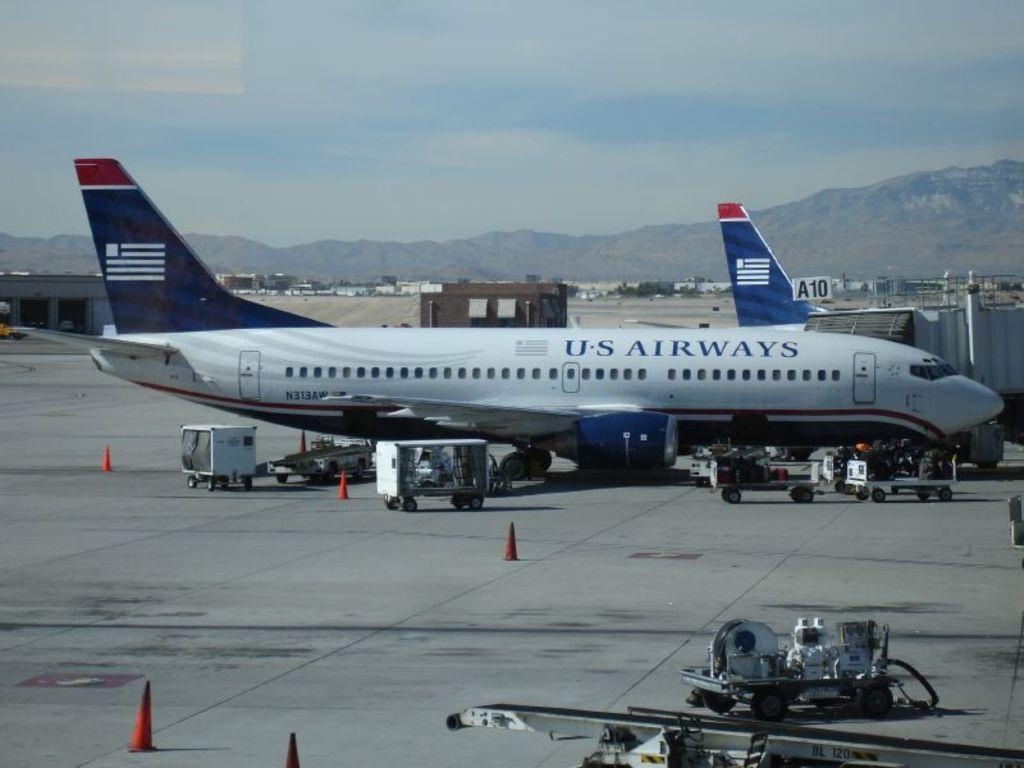What airline are we getting on?
Give a very brief answer. Us airways. What is the planes call sign?
Your answer should be compact. N313aw. 